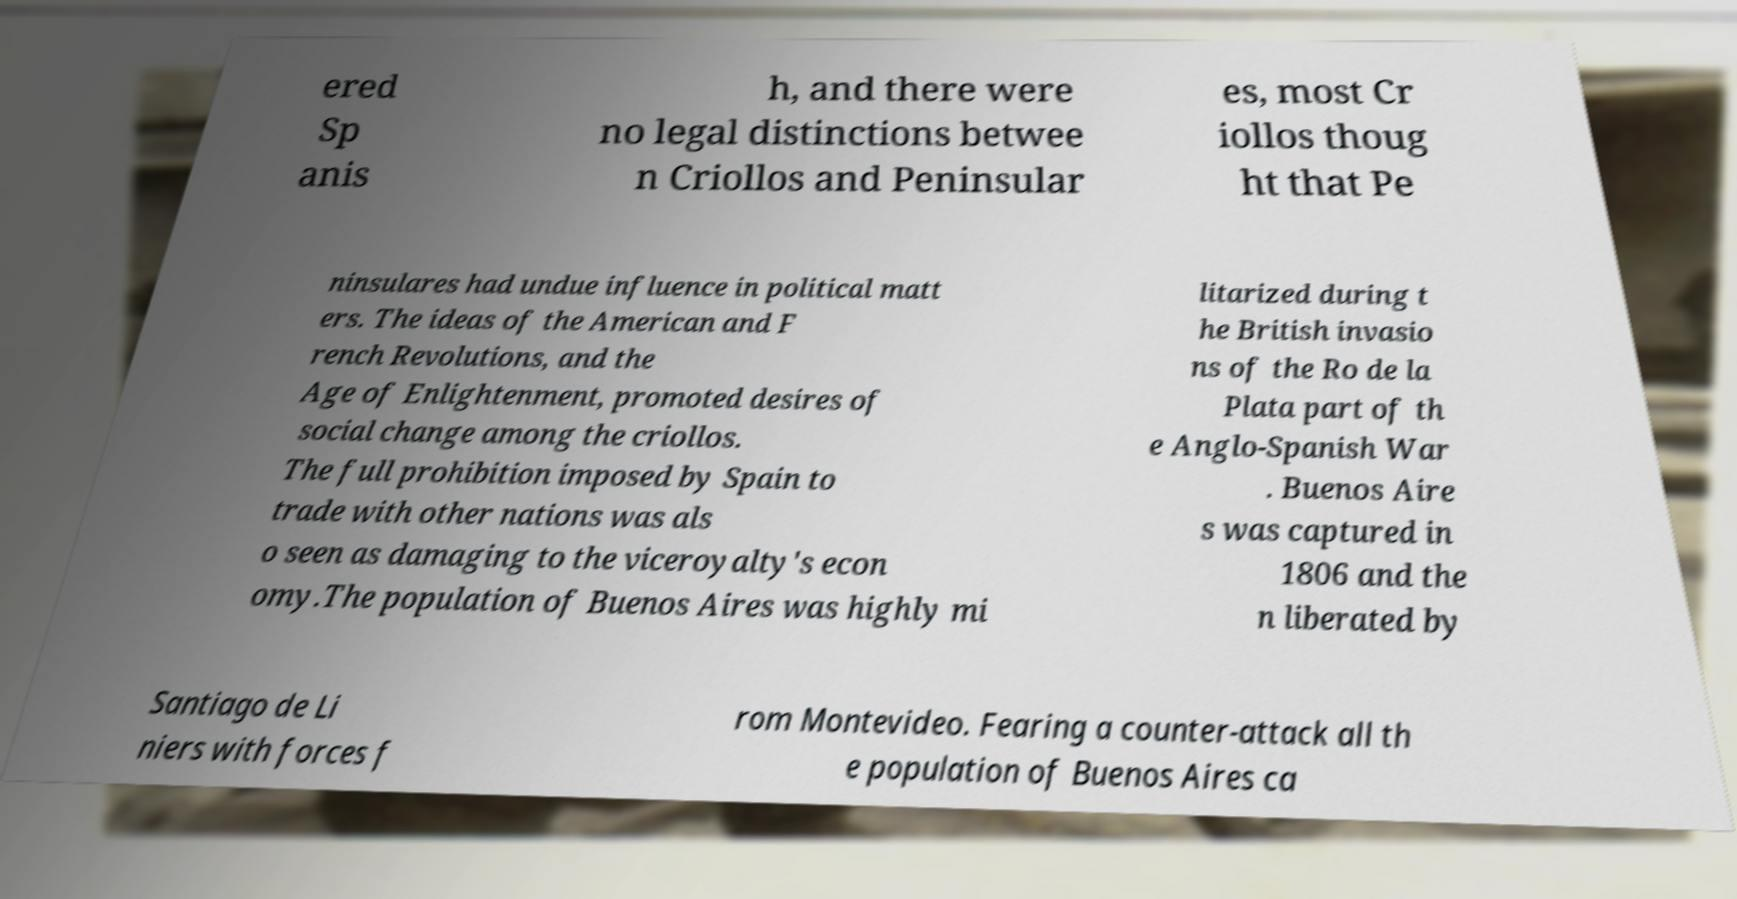Please read and relay the text visible in this image. What does it say? ered Sp anis h, and there were no legal distinctions betwee n Criollos and Peninsular es, most Cr iollos thoug ht that Pe ninsulares had undue influence in political matt ers. The ideas of the American and F rench Revolutions, and the Age of Enlightenment, promoted desires of social change among the criollos. The full prohibition imposed by Spain to trade with other nations was als o seen as damaging to the viceroyalty's econ omy.The population of Buenos Aires was highly mi litarized during t he British invasio ns of the Ro de la Plata part of th e Anglo-Spanish War . Buenos Aire s was captured in 1806 and the n liberated by Santiago de Li niers with forces f rom Montevideo. Fearing a counter-attack all th e population of Buenos Aires ca 